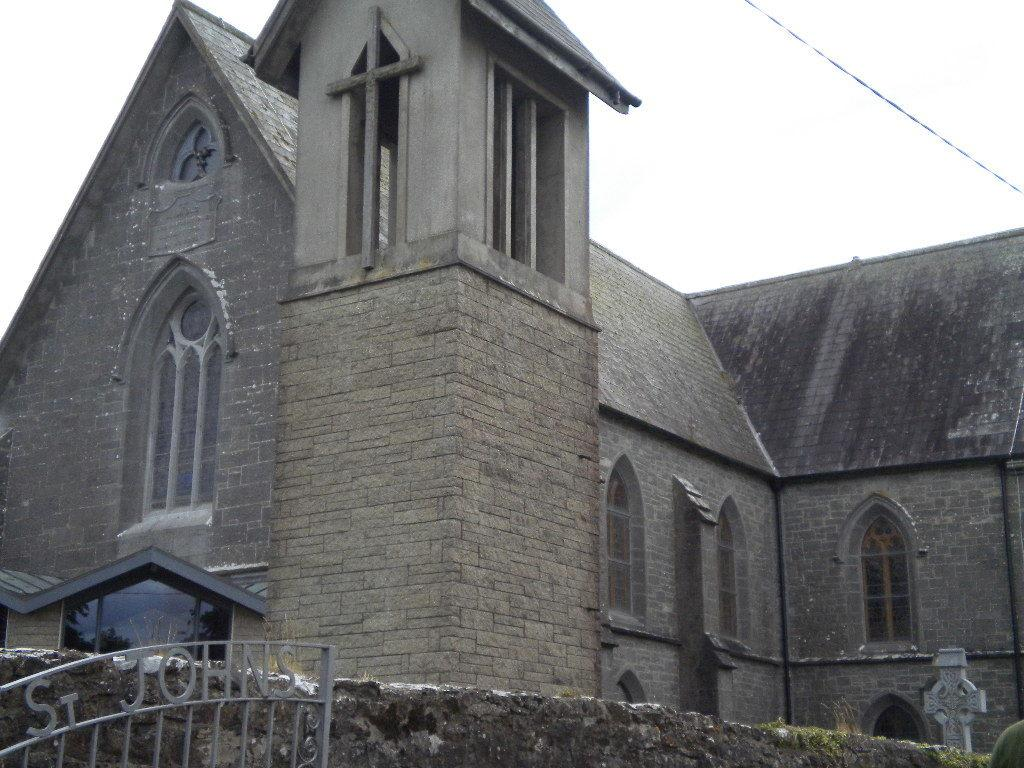What type of structure is present in the image? There is a building in the image. What is located in front of the building? The building has a wall and a gate in front of it. What can be seen above the building? The sky is visible above the building. What type of prose can be heard being recited by the baby in the image? There is no baby or prose present in the image; it features a building with a wall and a gate in front of it. 